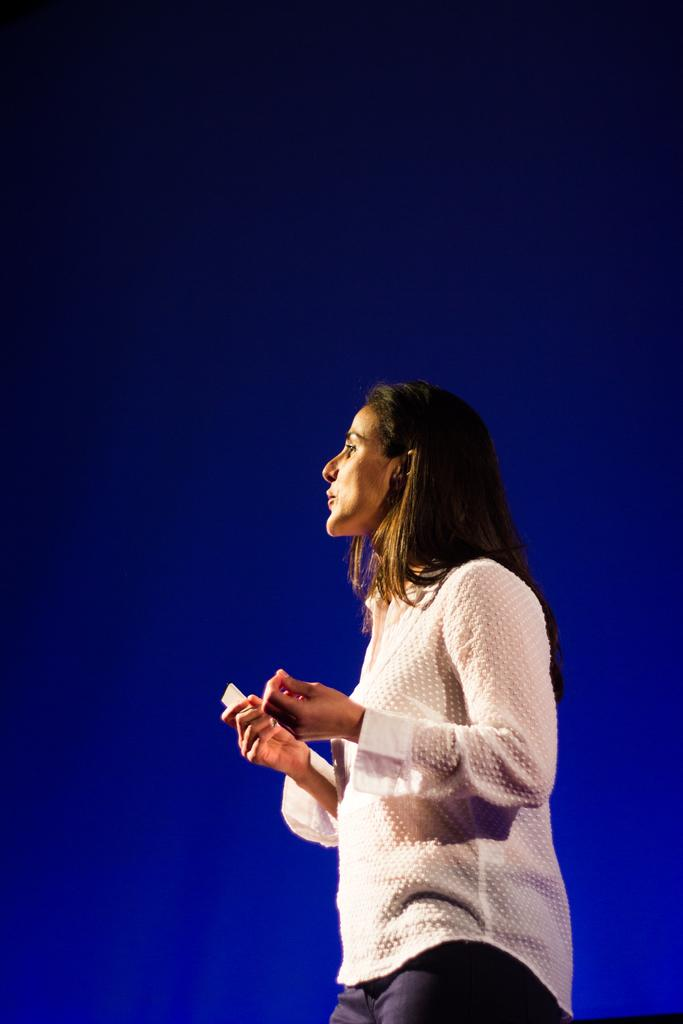What is present in the image? There is a woman in the image. What is the woman doing in the image? The woman is speaking. What type of clothing is the woman wearing? The woman is wearing a t-shirt. Can you see any rodents near the woman in the image? There is no mention of rodents or any animals in the image; it only features a woman who is speaking and wearing a t-shirt. 